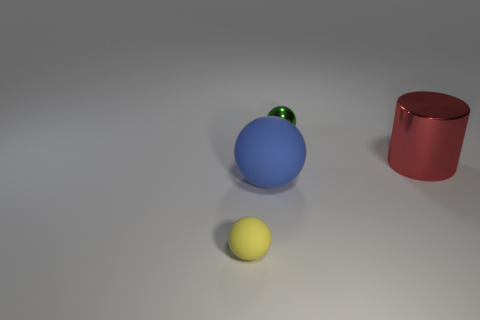There is a rubber sphere that is to the left of the big blue matte sphere; are there any tiny yellow rubber spheres that are behind it? Upon reviewing the image, there are no tiny yellow rubber spheres located behind the big blue matte sphere. The only visible spheres are the large blue matte sphere, a smaller green rubber sphere on top of it, and a yellow sphere in front. There are no other spheres present, particularly not behind the blue sphere. 